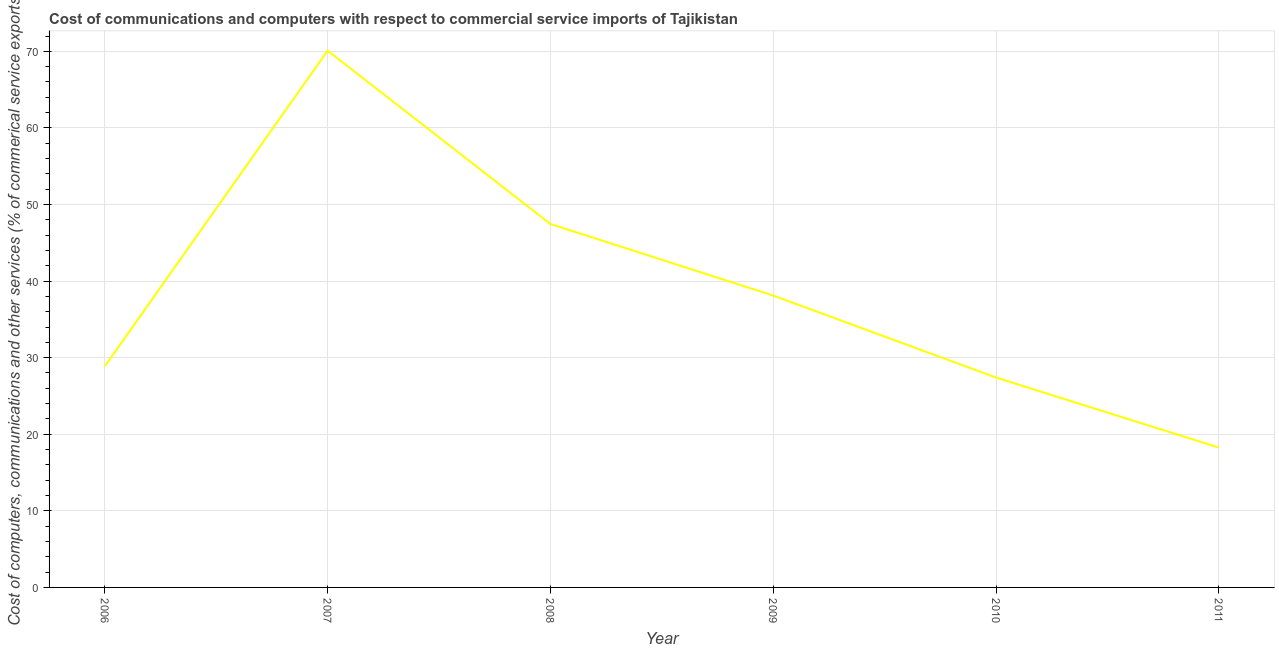What is the cost of communications in 2006?
Make the answer very short. 28.88. Across all years, what is the maximum  computer and other services?
Provide a succinct answer. 70.09. Across all years, what is the minimum cost of communications?
Offer a terse response. 18.26. In which year was the  computer and other services minimum?
Provide a short and direct response. 2011. What is the sum of the  computer and other services?
Provide a succinct answer. 230.2. What is the difference between the cost of communications in 2007 and 2010?
Offer a very short reply. 42.68. What is the average  computer and other services per year?
Make the answer very short. 38.37. What is the median cost of communications?
Your answer should be compact. 33.49. Do a majority of the years between 2009 and 2006 (inclusive) have cost of communications greater than 46 %?
Provide a short and direct response. Yes. What is the ratio of the  computer and other services in 2006 to that in 2008?
Provide a short and direct response. 0.61. Is the difference between the cost of communications in 2009 and 2010 greater than the difference between any two years?
Offer a very short reply. No. What is the difference between the highest and the second highest cost of communications?
Your response must be concise. 22.63. Is the sum of the cost of communications in 2006 and 2011 greater than the maximum cost of communications across all years?
Ensure brevity in your answer.  No. What is the difference between the highest and the lowest cost of communications?
Your answer should be very brief. 51.83. In how many years, is the  computer and other services greater than the average  computer and other services taken over all years?
Keep it short and to the point. 2. Does the  computer and other services monotonically increase over the years?
Provide a short and direct response. No. How many lines are there?
Provide a short and direct response. 1. How many years are there in the graph?
Your response must be concise. 6. Are the values on the major ticks of Y-axis written in scientific E-notation?
Keep it short and to the point. No. Does the graph contain grids?
Keep it short and to the point. Yes. What is the title of the graph?
Provide a succinct answer. Cost of communications and computers with respect to commercial service imports of Tajikistan. What is the label or title of the X-axis?
Offer a very short reply. Year. What is the label or title of the Y-axis?
Provide a succinct answer. Cost of computers, communications and other services (% of commerical service exports). What is the Cost of computers, communications and other services (% of commerical service exports) of 2006?
Make the answer very short. 28.88. What is the Cost of computers, communications and other services (% of commerical service exports) of 2007?
Your answer should be compact. 70.09. What is the Cost of computers, communications and other services (% of commerical service exports) in 2008?
Your response must be concise. 47.46. What is the Cost of computers, communications and other services (% of commerical service exports) of 2009?
Your answer should be very brief. 38.11. What is the Cost of computers, communications and other services (% of commerical service exports) of 2010?
Ensure brevity in your answer.  27.41. What is the Cost of computers, communications and other services (% of commerical service exports) in 2011?
Your response must be concise. 18.26. What is the difference between the Cost of computers, communications and other services (% of commerical service exports) in 2006 and 2007?
Keep it short and to the point. -41.21. What is the difference between the Cost of computers, communications and other services (% of commerical service exports) in 2006 and 2008?
Offer a very short reply. -18.58. What is the difference between the Cost of computers, communications and other services (% of commerical service exports) in 2006 and 2009?
Provide a succinct answer. -9.23. What is the difference between the Cost of computers, communications and other services (% of commerical service exports) in 2006 and 2010?
Provide a succinct answer. 1.47. What is the difference between the Cost of computers, communications and other services (% of commerical service exports) in 2006 and 2011?
Provide a short and direct response. 10.62. What is the difference between the Cost of computers, communications and other services (% of commerical service exports) in 2007 and 2008?
Make the answer very short. 22.63. What is the difference between the Cost of computers, communications and other services (% of commerical service exports) in 2007 and 2009?
Your answer should be compact. 31.98. What is the difference between the Cost of computers, communications and other services (% of commerical service exports) in 2007 and 2010?
Provide a short and direct response. 42.68. What is the difference between the Cost of computers, communications and other services (% of commerical service exports) in 2007 and 2011?
Ensure brevity in your answer.  51.83. What is the difference between the Cost of computers, communications and other services (% of commerical service exports) in 2008 and 2009?
Your response must be concise. 9.35. What is the difference between the Cost of computers, communications and other services (% of commerical service exports) in 2008 and 2010?
Your answer should be compact. 20.05. What is the difference between the Cost of computers, communications and other services (% of commerical service exports) in 2008 and 2011?
Offer a very short reply. 29.19. What is the difference between the Cost of computers, communications and other services (% of commerical service exports) in 2009 and 2010?
Provide a short and direct response. 10.7. What is the difference between the Cost of computers, communications and other services (% of commerical service exports) in 2009 and 2011?
Offer a terse response. 19.85. What is the difference between the Cost of computers, communications and other services (% of commerical service exports) in 2010 and 2011?
Ensure brevity in your answer.  9.14. What is the ratio of the Cost of computers, communications and other services (% of commerical service exports) in 2006 to that in 2007?
Provide a succinct answer. 0.41. What is the ratio of the Cost of computers, communications and other services (% of commerical service exports) in 2006 to that in 2008?
Offer a very short reply. 0.61. What is the ratio of the Cost of computers, communications and other services (% of commerical service exports) in 2006 to that in 2009?
Provide a short and direct response. 0.76. What is the ratio of the Cost of computers, communications and other services (% of commerical service exports) in 2006 to that in 2010?
Provide a short and direct response. 1.05. What is the ratio of the Cost of computers, communications and other services (% of commerical service exports) in 2006 to that in 2011?
Offer a very short reply. 1.58. What is the ratio of the Cost of computers, communications and other services (% of commerical service exports) in 2007 to that in 2008?
Ensure brevity in your answer.  1.48. What is the ratio of the Cost of computers, communications and other services (% of commerical service exports) in 2007 to that in 2009?
Your answer should be very brief. 1.84. What is the ratio of the Cost of computers, communications and other services (% of commerical service exports) in 2007 to that in 2010?
Provide a succinct answer. 2.56. What is the ratio of the Cost of computers, communications and other services (% of commerical service exports) in 2007 to that in 2011?
Your answer should be very brief. 3.84. What is the ratio of the Cost of computers, communications and other services (% of commerical service exports) in 2008 to that in 2009?
Offer a very short reply. 1.25. What is the ratio of the Cost of computers, communications and other services (% of commerical service exports) in 2008 to that in 2010?
Provide a short and direct response. 1.73. What is the ratio of the Cost of computers, communications and other services (% of commerical service exports) in 2008 to that in 2011?
Make the answer very short. 2.6. What is the ratio of the Cost of computers, communications and other services (% of commerical service exports) in 2009 to that in 2010?
Keep it short and to the point. 1.39. What is the ratio of the Cost of computers, communications and other services (% of commerical service exports) in 2009 to that in 2011?
Your response must be concise. 2.09. What is the ratio of the Cost of computers, communications and other services (% of commerical service exports) in 2010 to that in 2011?
Your response must be concise. 1.5. 